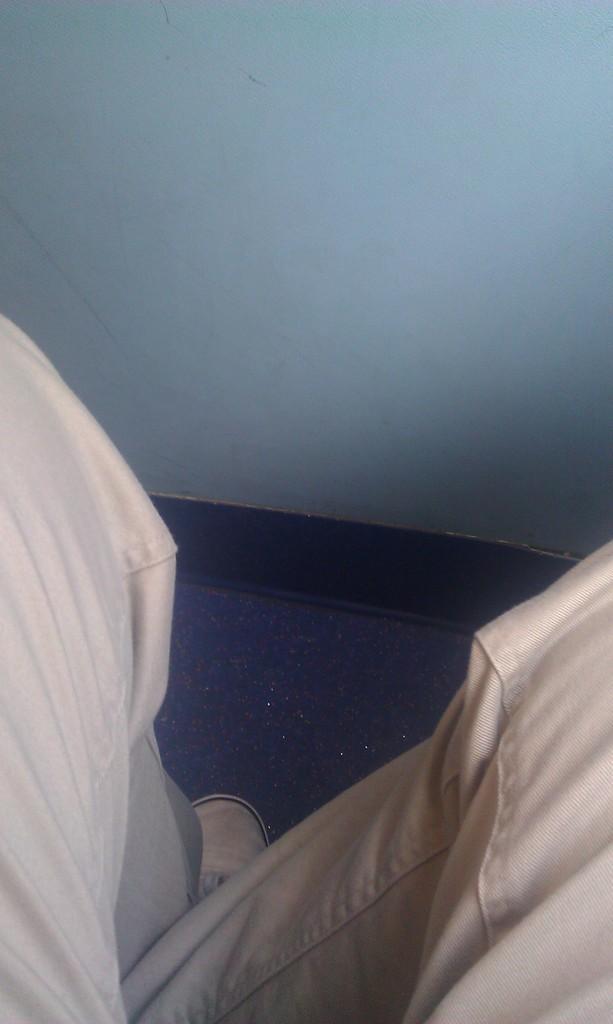In one or two sentences, can you explain what this image depicts? In the center of the image we can see human legs and one shoe. In the background there is a wall. 